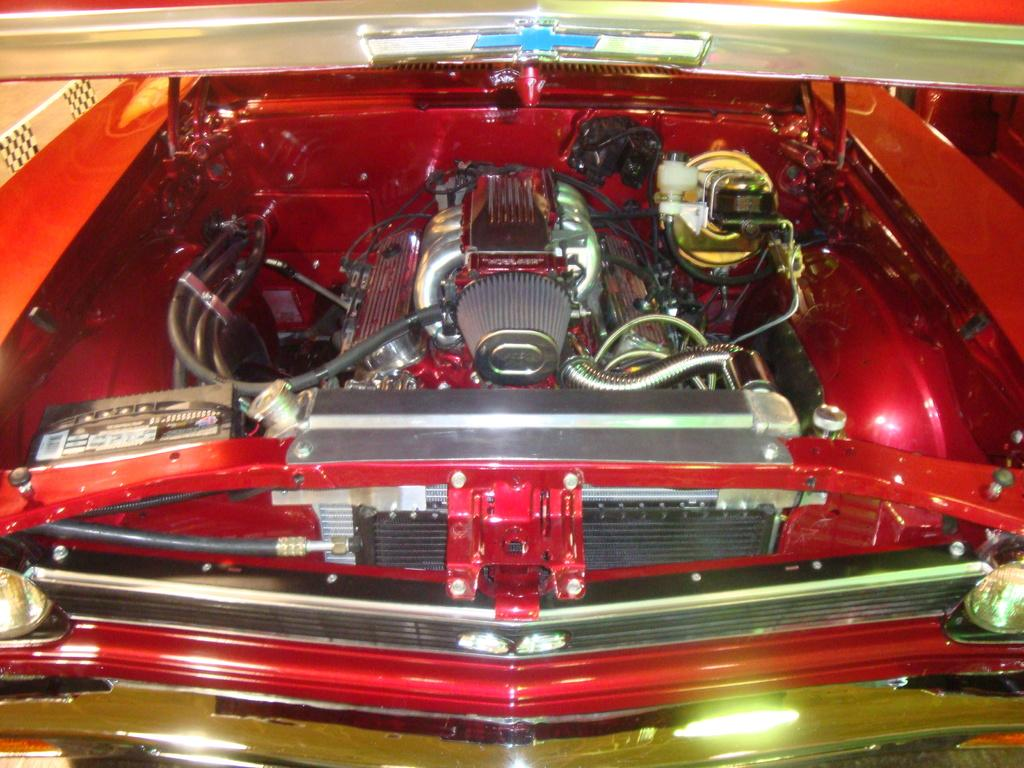What type of vehicle is in the image? There is a red colored vehicle in the image. What part of the vehicle is visible in the image? The engine of the vehicle is visible. What colors can be seen on the engine? The engine has silver, red, black, and gold colors. What is the color of the logo in the image? The logo in the image is blue colored. How many visitors can be seen in the image? There are no visitors present in the image; it only features a red colored vehicle with a visible engine and a blue colored logo. 